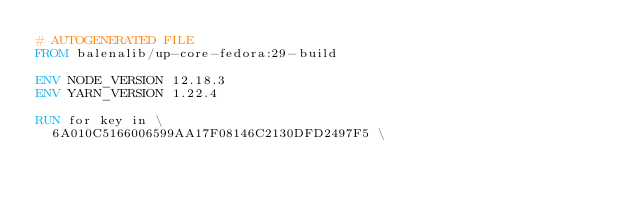<code> <loc_0><loc_0><loc_500><loc_500><_Dockerfile_># AUTOGENERATED FILE
FROM balenalib/up-core-fedora:29-build

ENV NODE_VERSION 12.18.3
ENV YARN_VERSION 1.22.4

RUN for key in \
	6A010C5166006599AA17F08146C2130DFD2497F5 \</code> 